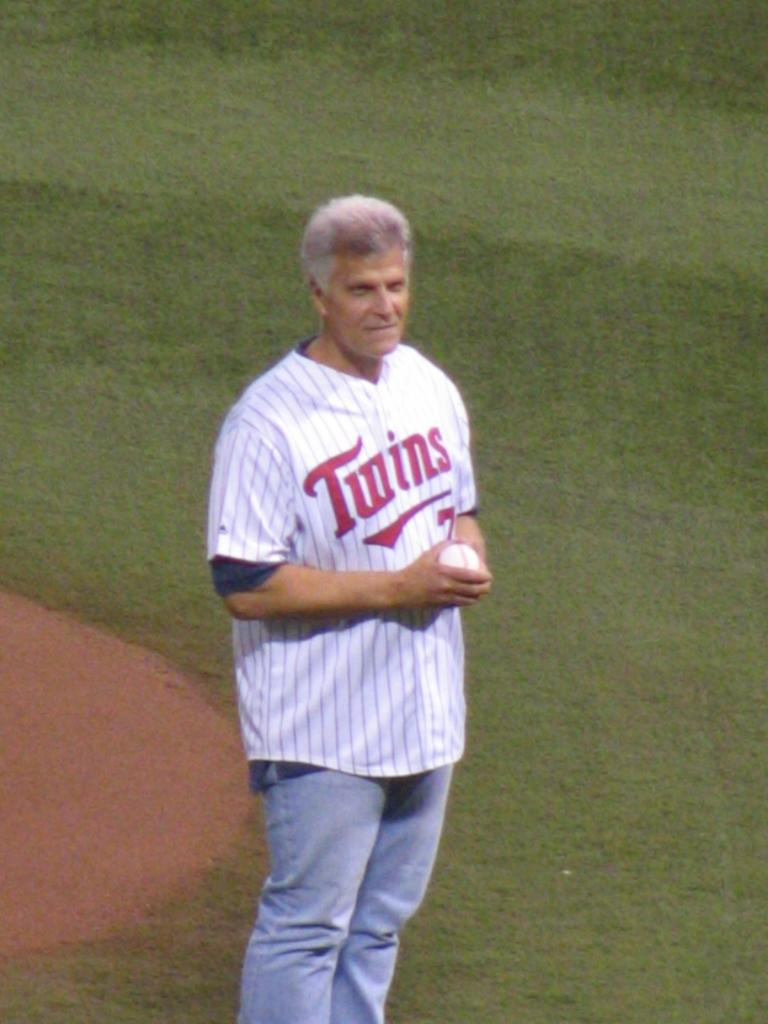<image>
Share a concise interpretation of the image provided. A man is standing on a baseball field with a Twins jersey on. 